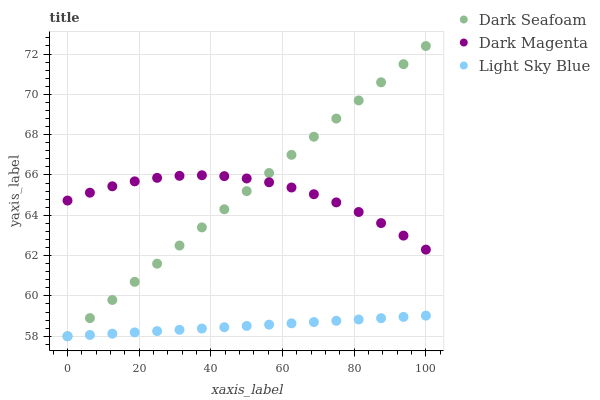Does Light Sky Blue have the minimum area under the curve?
Answer yes or no. Yes. Does Dark Seafoam have the maximum area under the curve?
Answer yes or no. Yes. Does Dark Magenta have the minimum area under the curve?
Answer yes or no. No. Does Dark Magenta have the maximum area under the curve?
Answer yes or no. No. Is Light Sky Blue the smoothest?
Answer yes or no. Yes. Is Dark Magenta the roughest?
Answer yes or no. Yes. Is Dark Magenta the smoothest?
Answer yes or no. No. Is Light Sky Blue the roughest?
Answer yes or no. No. Does Dark Seafoam have the lowest value?
Answer yes or no. Yes. Does Dark Magenta have the lowest value?
Answer yes or no. No. Does Dark Seafoam have the highest value?
Answer yes or no. Yes. Does Dark Magenta have the highest value?
Answer yes or no. No. Is Light Sky Blue less than Dark Magenta?
Answer yes or no. Yes. Is Dark Magenta greater than Light Sky Blue?
Answer yes or no. Yes. Does Dark Seafoam intersect Dark Magenta?
Answer yes or no. Yes. Is Dark Seafoam less than Dark Magenta?
Answer yes or no. No. Is Dark Seafoam greater than Dark Magenta?
Answer yes or no. No. Does Light Sky Blue intersect Dark Magenta?
Answer yes or no. No. 